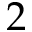<formula> <loc_0><loc_0><loc_500><loc_500>2</formula> 